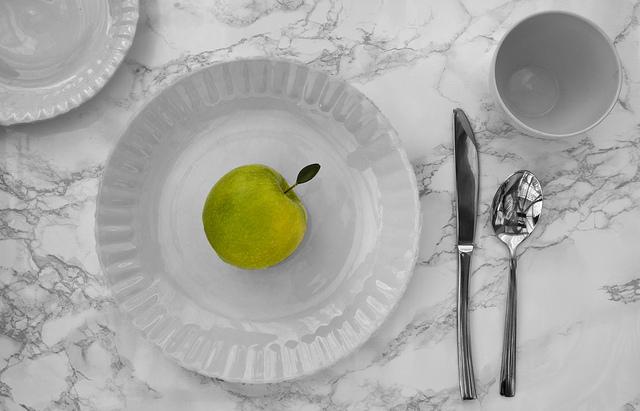Is the apple real?
Quick response, please. Yes. Is the cup full?
Short answer required. No. What color is the plate?
Answer briefly. White. 